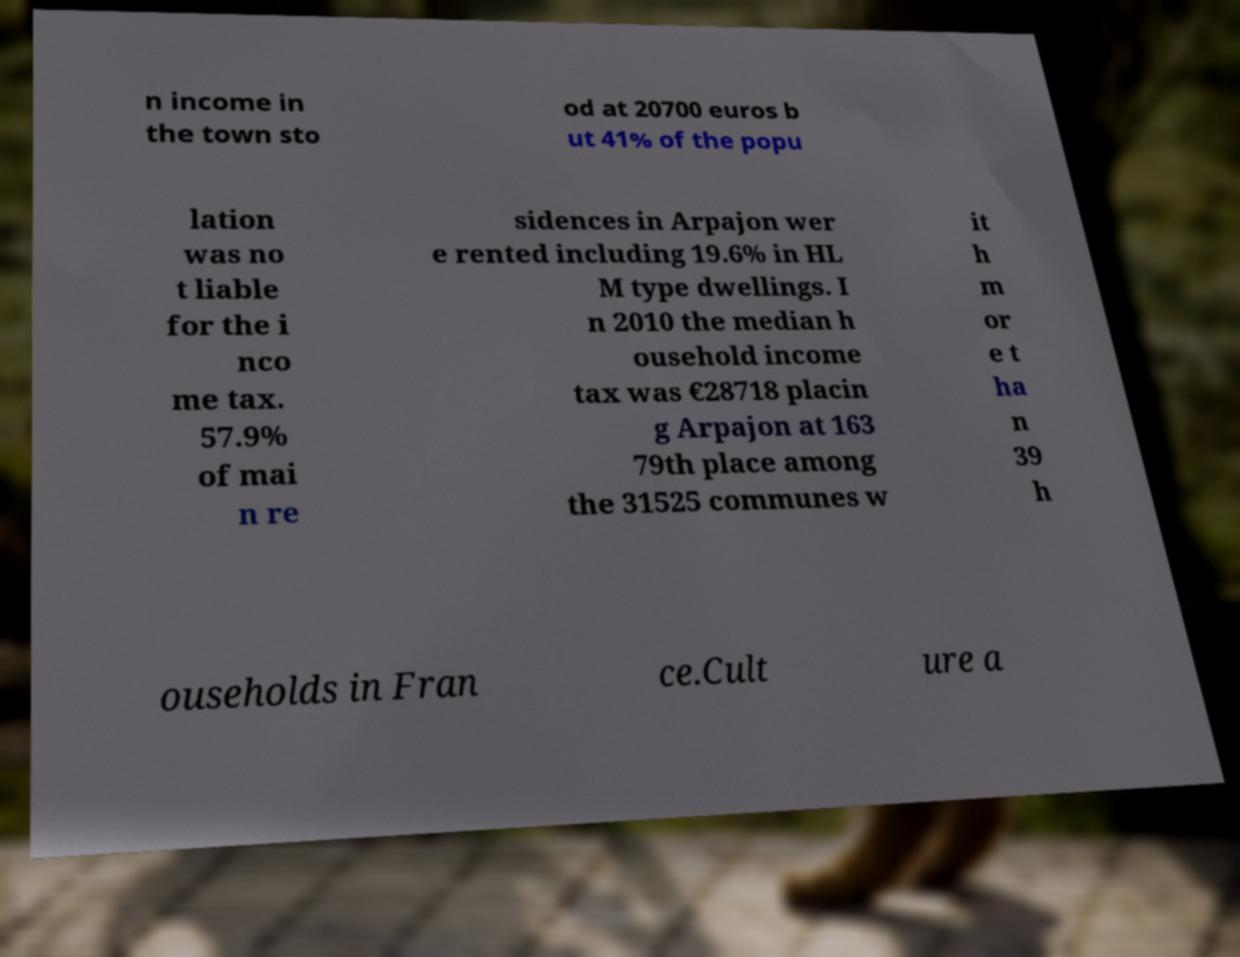Can you read and provide the text displayed in the image?This photo seems to have some interesting text. Can you extract and type it out for me? n income in the town sto od at 20700 euros b ut 41% of the popu lation was no t liable for the i nco me tax. 57.9% of mai n re sidences in Arpajon wer e rented including 19.6% in HL M type dwellings. I n 2010 the median h ousehold income tax was €28718 placin g Arpajon at 163 79th place among the 31525 communes w it h m or e t ha n 39 h ouseholds in Fran ce.Cult ure a 